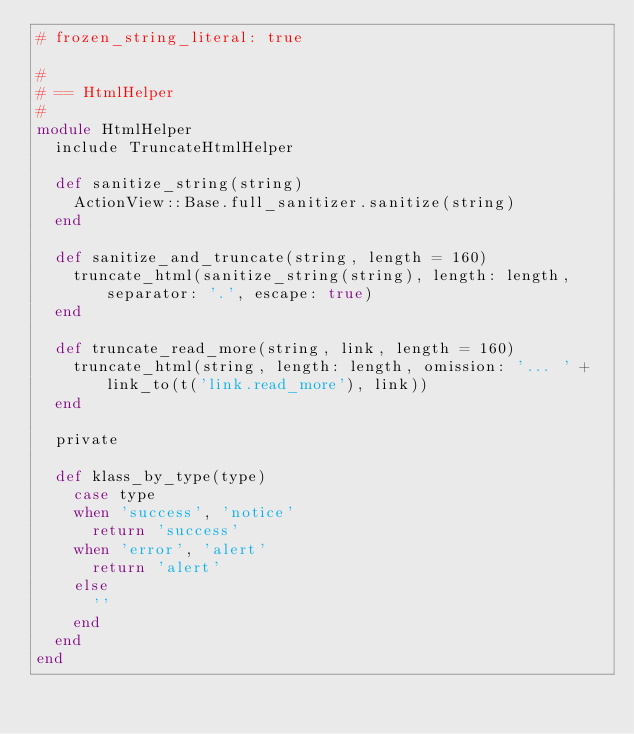<code> <loc_0><loc_0><loc_500><loc_500><_Ruby_># frozen_string_literal: true

#
# == HtmlHelper
#
module HtmlHelper
  include TruncateHtmlHelper

  def sanitize_string(string)
    ActionView::Base.full_sanitizer.sanitize(string)
  end

  def sanitize_and_truncate(string, length = 160)
    truncate_html(sanitize_string(string), length: length, separator: '.', escape: true)
  end

  def truncate_read_more(string, link, length = 160)
    truncate_html(string, length: length, omission: '... ' + link_to(t('link.read_more'), link))
  end

  private

  def klass_by_type(type)
    case type
    when 'success', 'notice'
      return 'success'
    when 'error', 'alert'
      return 'alert'
    else
      ''
    end
  end
end
</code> 